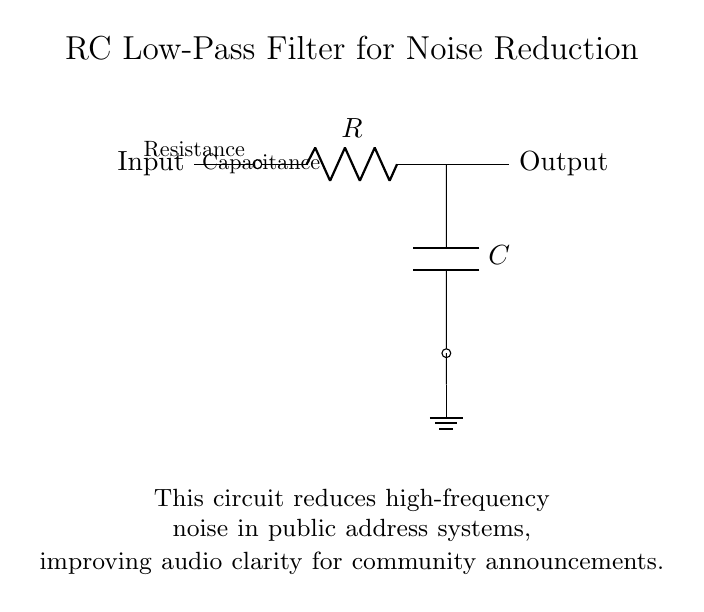What is the component used for resistance in this circuit? The circuit diagram shows the letter "R" next to a resistor symbol, indicating that it is the resistance component.
Answer: R What is the component used for capacitance in this circuit? The letter "C" next to a capacitor symbol in the diagram indicates that it is the capacitance component.
Answer: C What is the purpose of this RC low-pass filter circuit? The circuit description below the diagram states it is used for reducing high-frequency noise in public address systems, thus improving audio clarity.
Answer: Noise reduction What is the connection type for the output in this circuit? The "Output" label indicates that it is a direct connection from the resistance component leading to the output point, which implies it is a terminated connection.
Answer: Direct connection What happens to high-frequency signals in this circuit? As it is a low-pass filter, high-frequency signals are primarily attenuated or reduced while allowing lower frequencies to pass through.
Answer: Attenuated What does the ground symbol in the circuit signify? The ground symbol indicates a common reference point for the circuit, which is essential for defining the zero voltage level in the circuit design.
Answer: Common reference point What is the role of the resistor in the low-pass filter? The resistor in parallel with the capacitor determines the cutoff frequency of the filter, controlling which frequencies are allowed to pass through to the output.
Answer: Determines cutoff frequency 